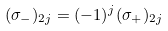Convert formula to latex. <formula><loc_0><loc_0><loc_500><loc_500>( \sigma _ { - } ) _ { 2 j } = ( - 1 ) ^ { j } ( \sigma _ { + } ) _ { 2 j }</formula> 